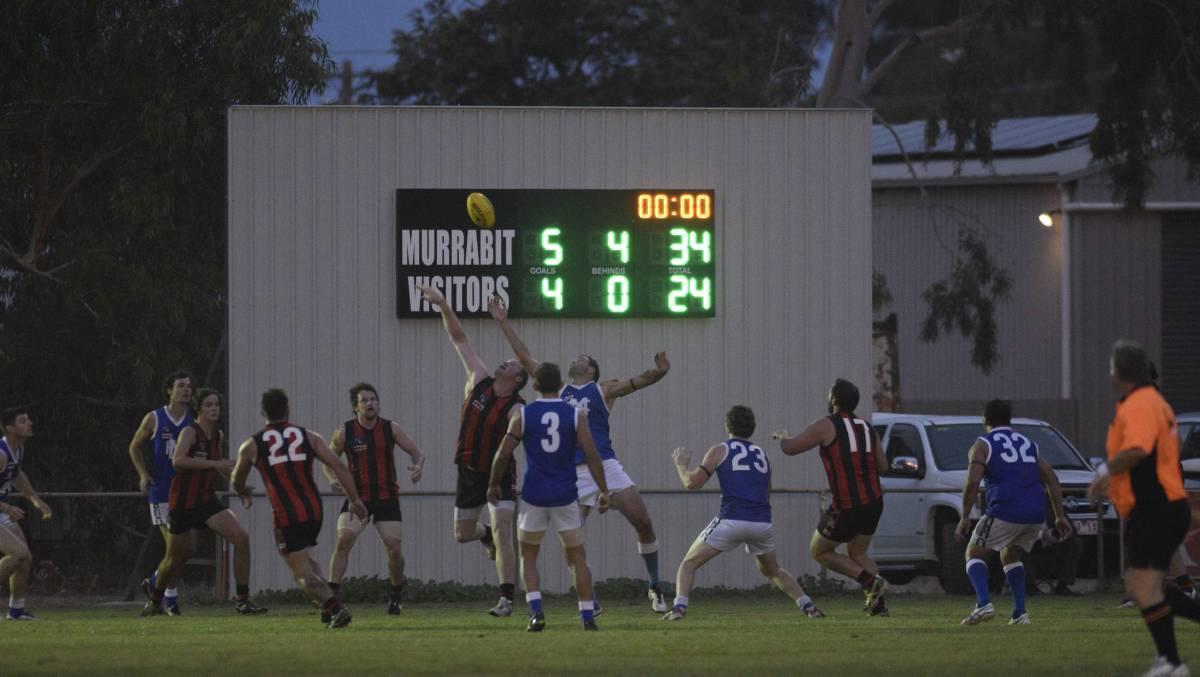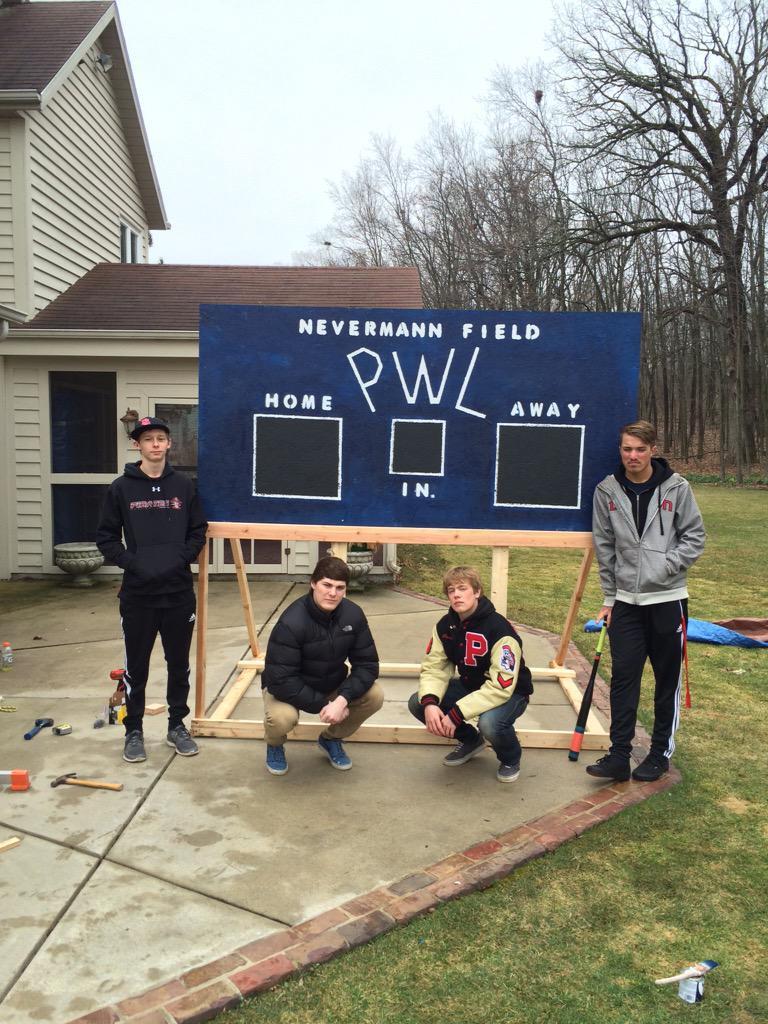The first image is the image on the left, the second image is the image on the right. Analyze the images presented: Is the assertion "One of the images shows a scoreboard with no people around and the other image shows a scoreboard with a team of players on the field." valid? Answer yes or no. No. 